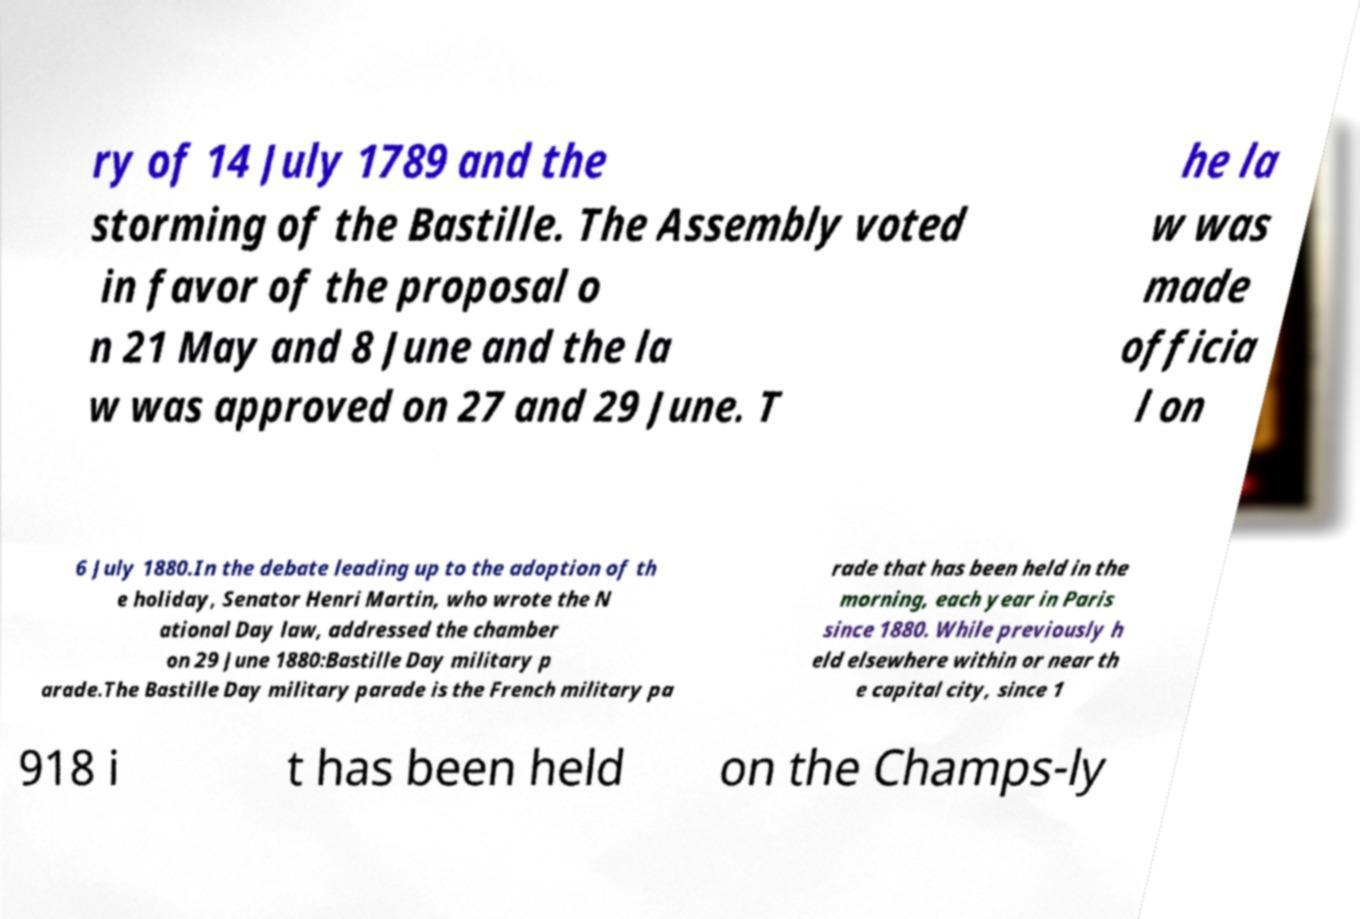Can you accurately transcribe the text from the provided image for me? ry of 14 July 1789 and the storming of the Bastille. The Assembly voted in favor of the proposal o n 21 May and 8 June and the la w was approved on 27 and 29 June. T he la w was made officia l on 6 July 1880.In the debate leading up to the adoption of th e holiday, Senator Henri Martin, who wrote the N ational Day law, addressed the chamber on 29 June 1880:Bastille Day military p arade.The Bastille Day military parade is the French military pa rade that has been held in the morning, each year in Paris since 1880. While previously h eld elsewhere within or near th e capital city, since 1 918 i t has been held on the Champs-ly 